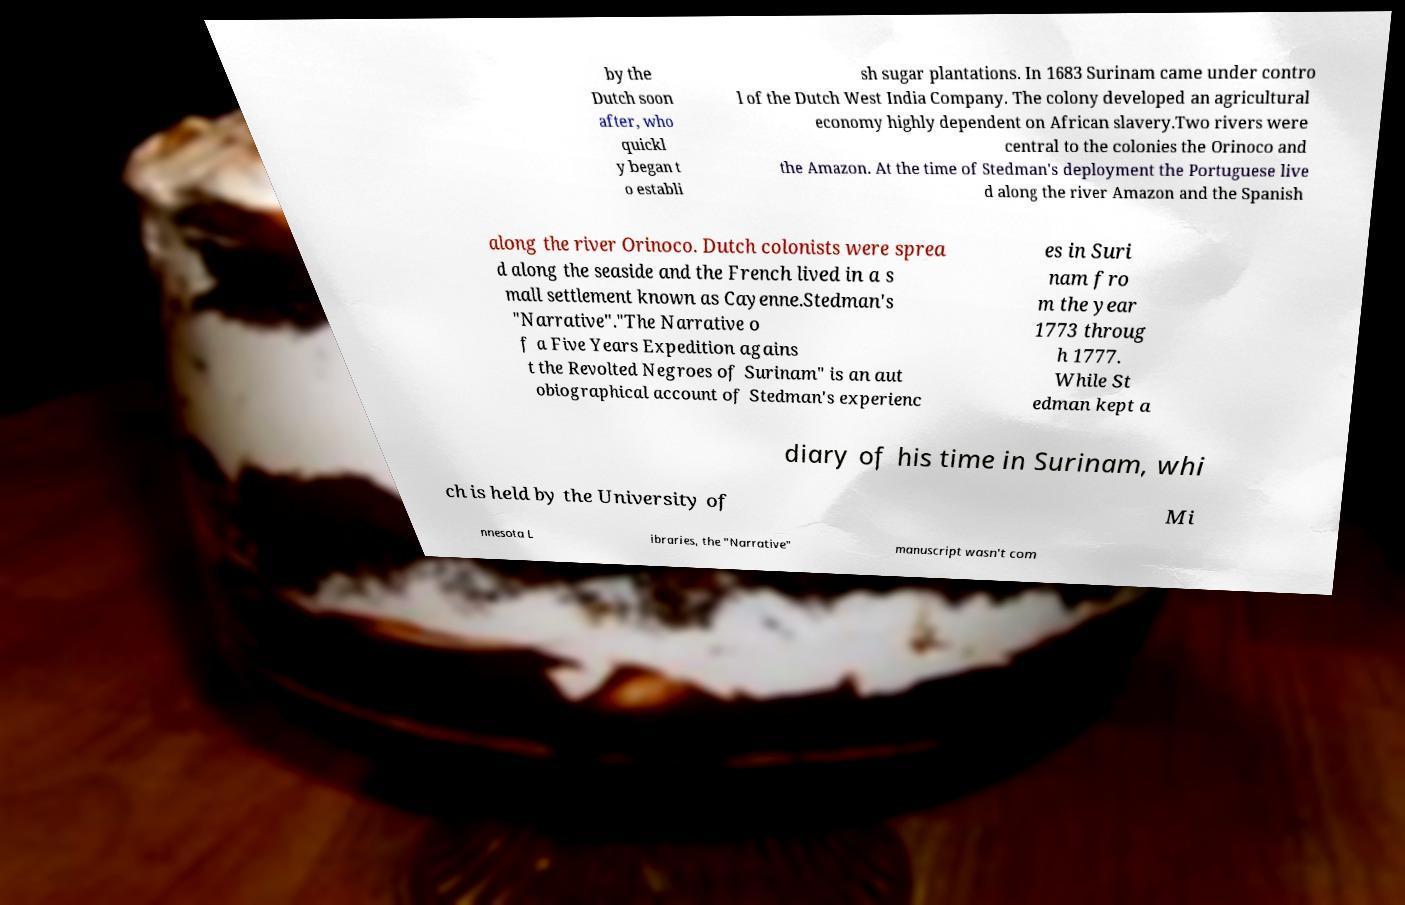Could you extract and type out the text from this image? by the Dutch soon after, who quickl y began t o establi sh sugar plantations. In 1683 Surinam came under contro l of the Dutch West India Company. The colony developed an agricultural economy highly dependent on African slavery.Two rivers were central to the colonies the Orinoco and the Amazon. At the time of Stedman's deployment the Portuguese live d along the river Amazon and the Spanish along the river Orinoco. Dutch colonists were sprea d along the seaside and the French lived in a s mall settlement known as Cayenne.Stedman's "Narrative"."The Narrative o f a Five Years Expedition agains t the Revolted Negroes of Surinam" is an aut obiographical account of Stedman's experienc es in Suri nam fro m the year 1773 throug h 1777. While St edman kept a diary of his time in Surinam, whi ch is held by the University of Mi nnesota L ibraries, the "Narrative" manuscript wasn't com 